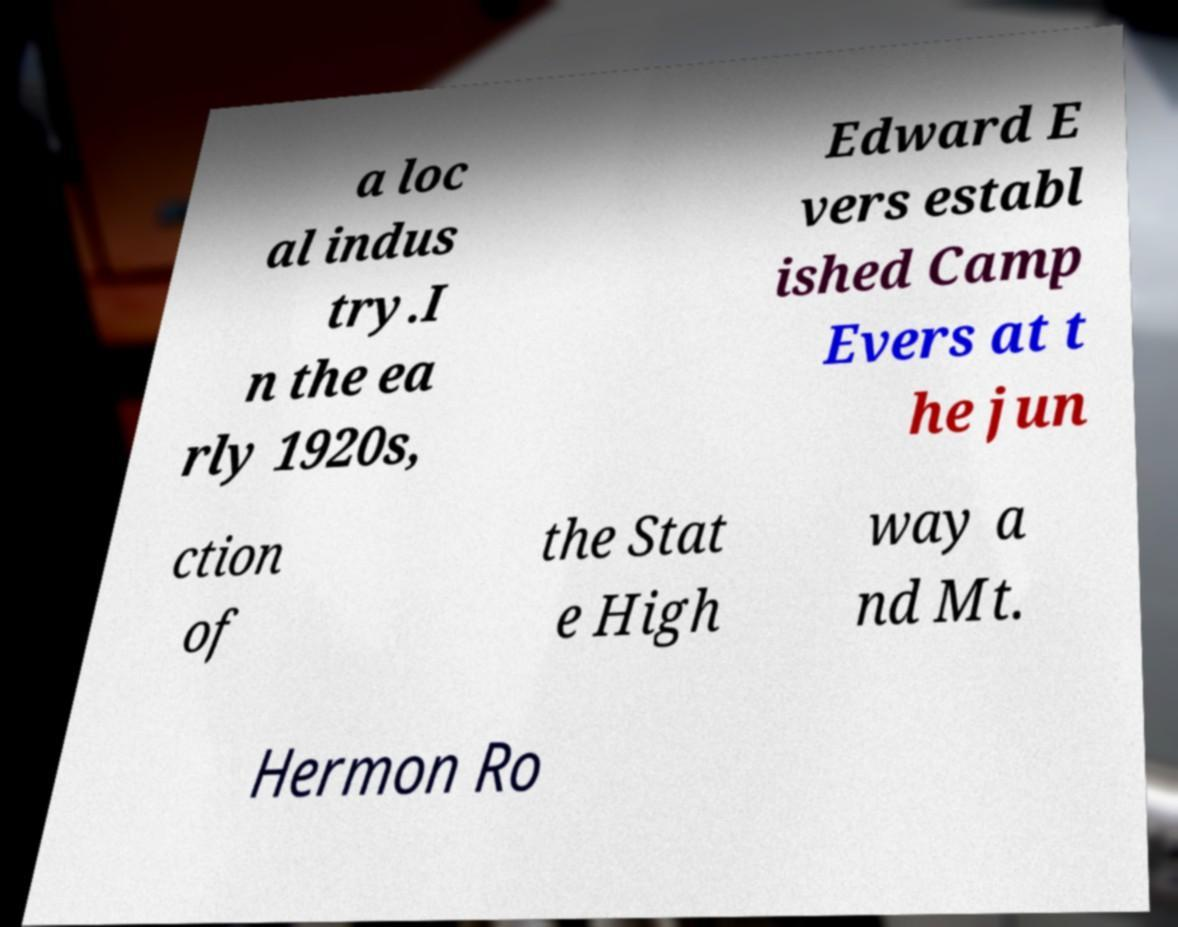Can you read and provide the text displayed in the image?This photo seems to have some interesting text. Can you extract and type it out for me? a loc al indus try.I n the ea rly 1920s, Edward E vers establ ished Camp Evers at t he jun ction of the Stat e High way a nd Mt. Hermon Ro 